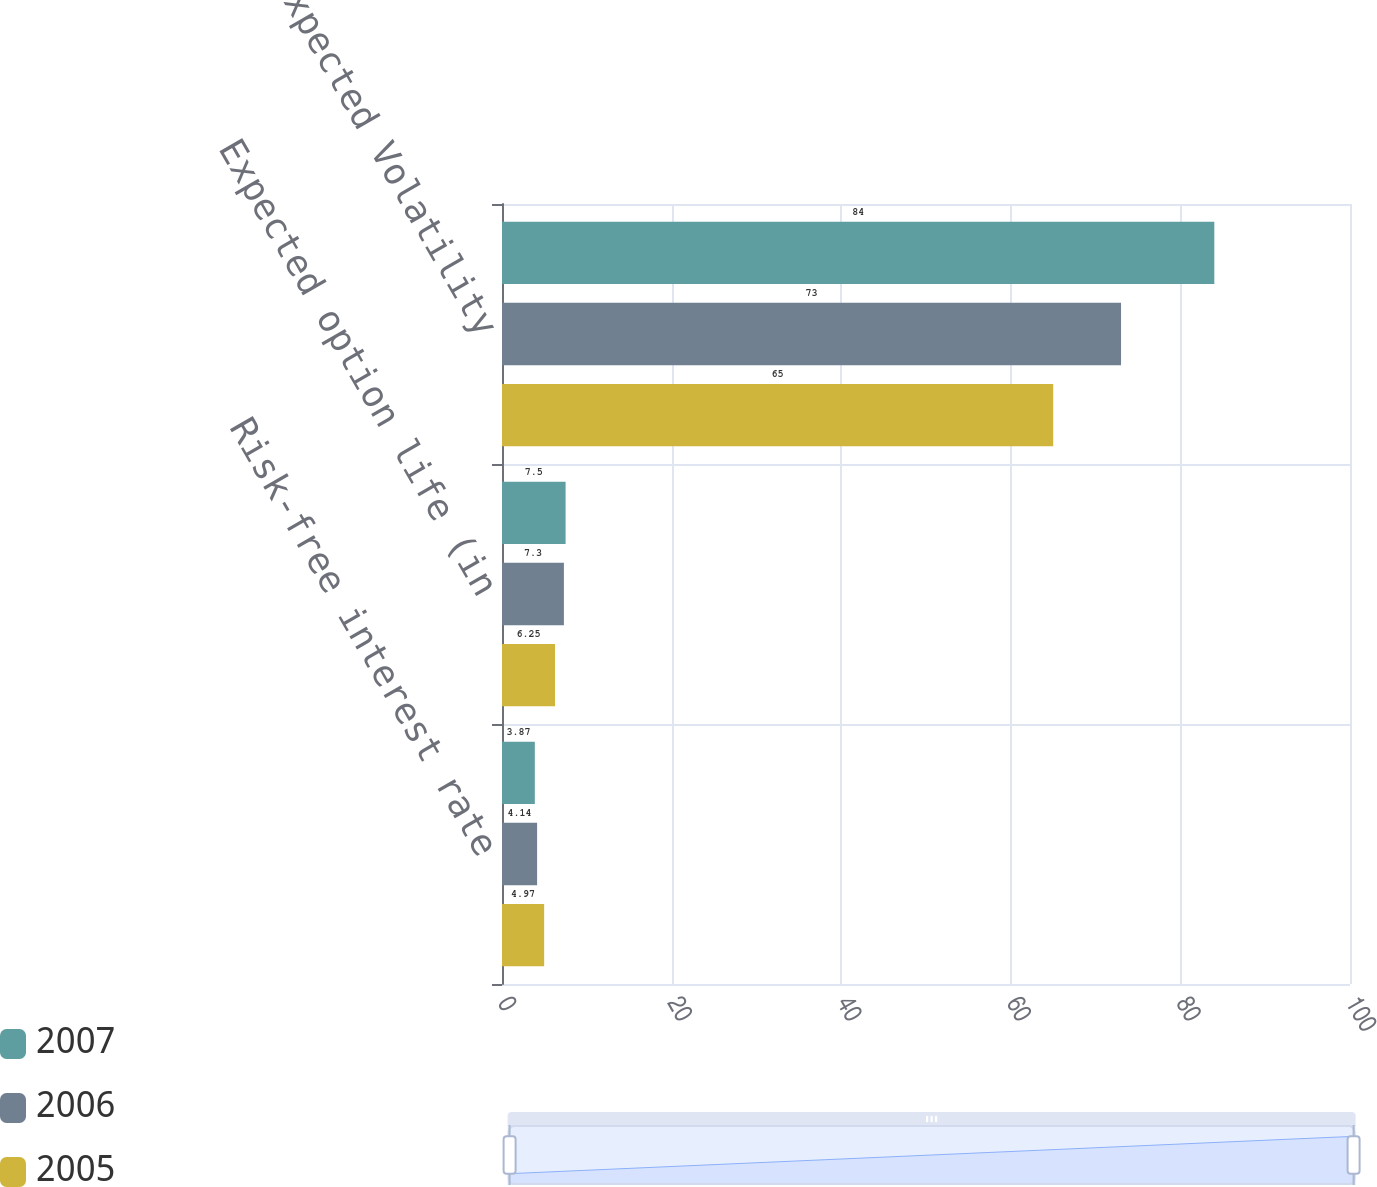<chart> <loc_0><loc_0><loc_500><loc_500><stacked_bar_chart><ecel><fcel>Risk-free interest rate<fcel>Expected option life (in<fcel>Expected Volatility<nl><fcel>2007<fcel>3.87<fcel>7.5<fcel>84<nl><fcel>2006<fcel>4.14<fcel>7.3<fcel>73<nl><fcel>2005<fcel>4.97<fcel>6.25<fcel>65<nl></chart> 